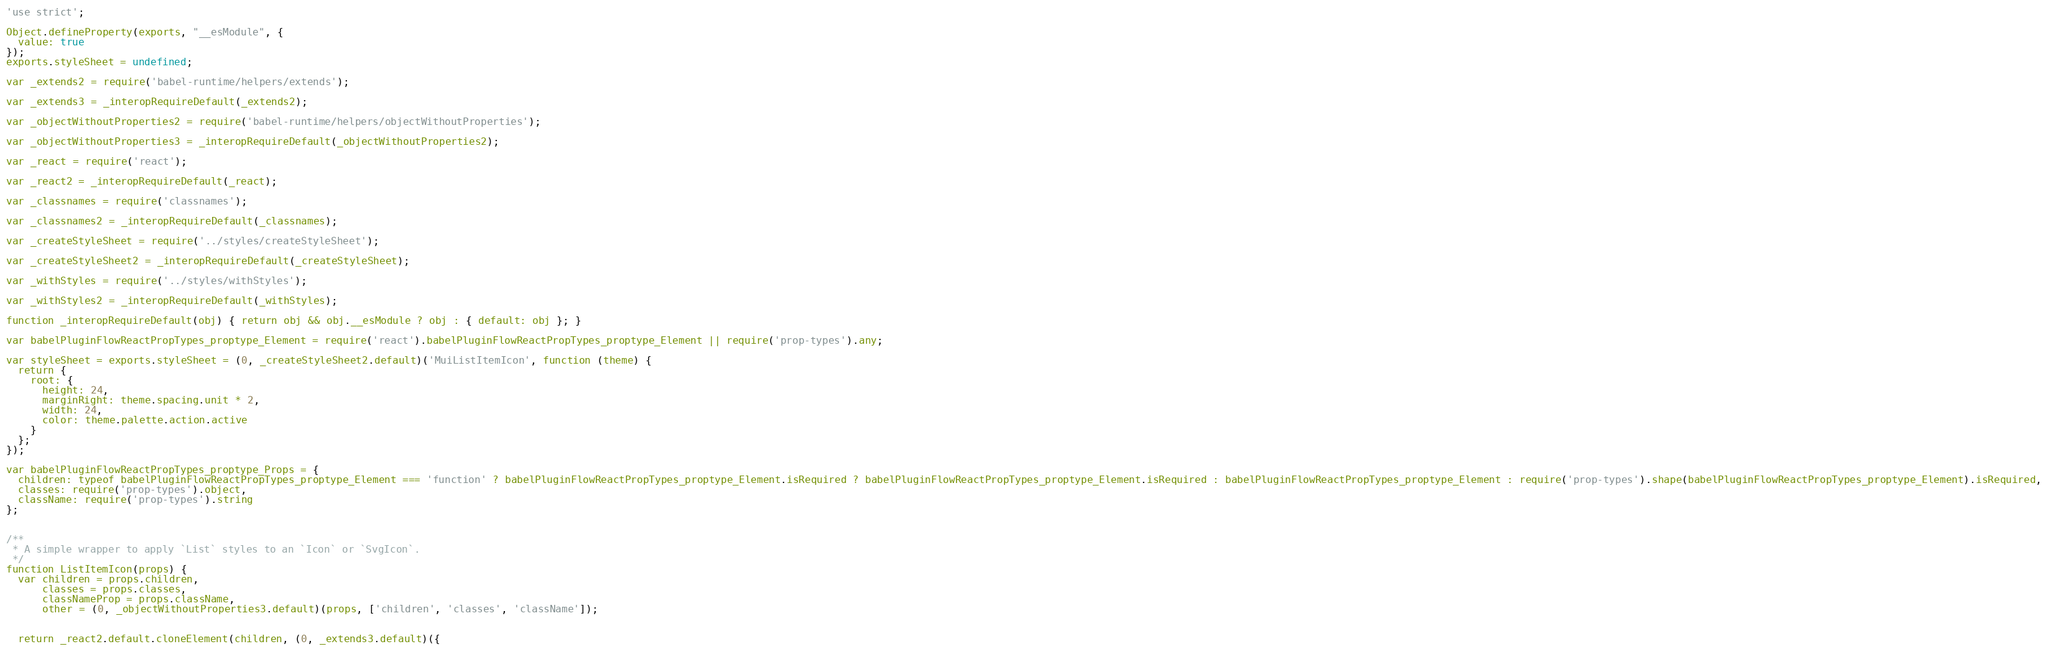<code> <loc_0><loc_0><loc_500><loc_500><_JavaScript_>'use strict';

Object.defineProperty(exports, "__esModule", {
  value: true
});
exports.styleSheet = undefined;

var _extends2 = require('babel-runtime/helpers/extends');

var _extends3 = _interopRequireDefault(_extends2);

var _objectWithoutProperties2 = require('babel-runtime/helpers/objectWithoutProperties');

var _objectWithoutProperties3 = _interopRequireDefault(_objectWithoutProperties2);

var _react = require('react');

var _react2 = _interopRequireDefault(_react);

var _classnames = require('classnames');

var _classnames2 = _interopRequireDefault(_classnames);

var _createStyleSheet = require('../styles/createStyleSheet');

var _createStyleSheet2 = _interopRequireDefault(_createStyleSheet);

var _withStyles = require('../styles/withStyles');

var _withStyles2 = _interopRequireDefault(_withStyles);

function _interopRequireDefault(obj) { return obj && obj.__esModule ? obj : { default: obj }; }

var babelPluginFlowReactPropTypes_proptype_Element = require('react').babelPluginFlowReactPropTypes_proptype_Element || require('prop-types').any;

var styleSheet = exports.styleSheet = (0, _createStyleSheet2.default)('MuiListItemIcon', function (theme) {
  return {
    root: {
      height: 24,
      marginRight: theme.spacing.unit * 2,
      width: 24,
      color: theme.palette.action.active
    }
  };
});

var babelPluginFlowReactPropTypes_proptype_Props = {
  children: typeof babelPluginFlowReactPropTypes_proptype_Element === 'function' ? babelPluginFlowReactPropTypes_proptype_Element.isRequired ? babelPluginFlowReactPropTypes_proptype_Element.isRequired : babelPluginFlowReactPropTypes_proptype_Element : require('prop-types').shape(babelPluginFlowReactPropTypes_proptype_Element).isRequired,
  classes: require('prop-types').object,
  className: require('prop-types').string
};


/**
 * A simple wrapper to apply `List` styles to an `Icon` or `SvgIcon`.
 */
function ListItemIcon(props) {
  var children = props.children,
      classes = props.classes,
      classNameProp = props.className,
      other = (0, _objectWithoutProperties3.default)(props, ['children', 'classes', 'className']);


  return _react2.default.cloneElement(children, (0, _extends3.default)({</code> 